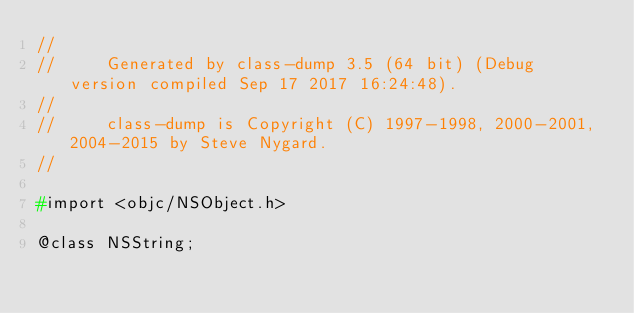<code> <loc_0><loc_0><loc_500><loc_500><_C_>//
//     Generated by class-dump 3.5 (64 bit) (Debug version compiled Sep 17 2017 16:24:48).
//
//     class-dump is Copyright (C) 1997-1998, 2000-2001, 2004-2015 by Steve Nygard.
//

#import <objc/NSObject.h>

@class NSString;</code> 